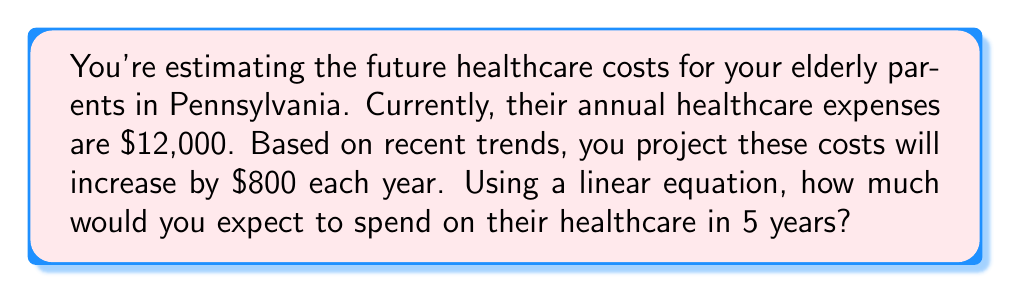Teach me how to tackle this problem. Let's approach this step-by-step using a linear equation:

1) Let $y$ represent the healthcare costs and $x$ represent the number of years from now.

2) The linear equation for this situation is:
   $y = mx + b$
   where $m$ is the rate of increase per year, and $b$ is the initial cost.

3) We know:
   - Initial cost (b) = $12,000
   - Rate of increase per year (m) = $800
   - We want to find the cost after 5 years, so x = 5

4) Plugging these values into our equation:
   $y = 800x + 12000$

5) Now, let's solve for y when x = 5:
   $y = 800(5) + 12000$
   $y = 4000 + 12000$
   $y = 16000$

Therefore, in 5 years, you can expect to spend $16,000 on your parents' healthcare.
Answer: $16,000 